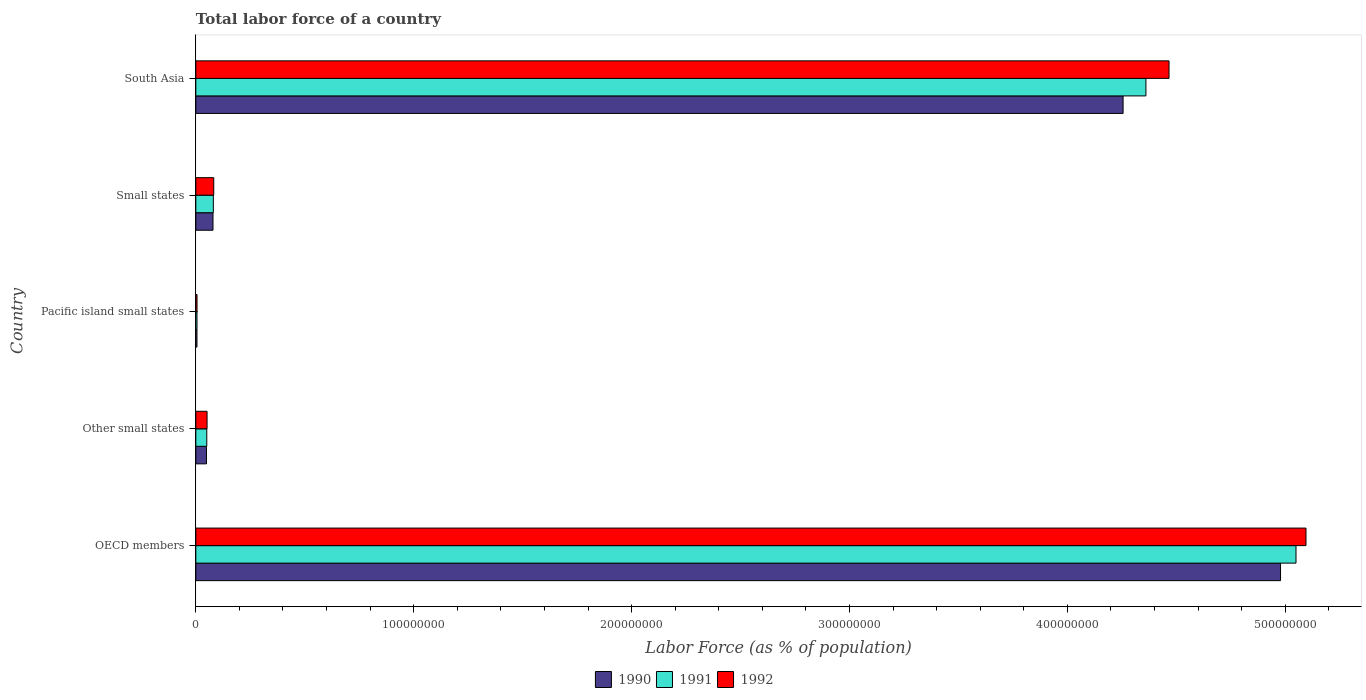How many groups of bars are there?
Provide a short and direct response. 5. Are the number of bars on each tick of the Y-axis equal?
Make the answer very short. Yes. How many bars are there on the 4th tick from the top?
Give a very brief answer. 3. How many bars are there on the 5th tick from the bottom?
Keep it short and to the point. 3. What is the label of the 3rd group of bars from the top?
Ensure brevity in your answer.  Pacific island small states. What is the percentage of labor force in 1990 in Pacific island small states?
Your response must be concise. 5.22e+05. Across all countries, what is the maximum percentage of labor force in 1992?
Make the answer very short. 5.10e+08. Across all countries, what is the minimum percentage of labor force in 1992?
Offer a terse response. 5.49e+05. In which country was the percentage of labor force in 1992 minimum?
Your response must be concise. Pacific island small states. What is the total percentage of labor force in 1991 in the graph?
Provide a short and direct response. 9.55e+08. What is the difference between the percentage of labor force in 1992 in OECD members and that in Other small states?
Your answer should be compact. 5.04e+08. What is the difference between the percentage of labor force in 1990 in Pacific island small states and the percentage of labor force in 1992 in Small states?
Ensure brevity in your answer.  -7.70e+06. What is the average percentage of labor force in 1990 per country?
Keep it short and to the point. 1.87e+08. What is the difference between the percentage of labor force in 1991 and percentage of labor force in 1992 in OECD members?
Your response must be concise. -4.58e+06. What is the ratio of the percentage of labor force in 1990 in OECD members to that in South Asia?
Make the answer very short. 1.17. Is the percentage of labor force in 1992 in OECD members less than that in Small states?
Keep it short and to the point. No. What is the difference between the highest and the second highest percentage of labor force in 1992?
Make the answer very short. 6.29e+07. What is the difference between the highest and the lowest percentage of labor force in 1991?
Make the answer very short. 5.04e+08. Is the sum of the percentage of labor force in 1990 in Pacific island small states and South Asia greater than the maximum percentage of labor force in 1992 across all countries?
Your answer should be very brief. No. What does the 2nd bar from the bottom in South Asia represents?
Provide a succinct answer. 1991. How many countries are there in the graph?
Make the answer very short. 5. What is the difference between two consecutive major ticks on the X-axis?
Offer a terse response. 1.00e+08. Does the graph contain any zero values?
Give a very brief answer. No. Does the graph contain grids?
Your answer should be very brief. No. What is the title of the graph?
Make the answer very short. Total labor force of a country. Does "1968" appear as one of the legend labels in the graph?
Provide a succinct answer. No. What is the label or title of the X-axis?
Make the answer very short. Labor Force (as % of population). What is the label or title of the Y-axis?
Your answer should be compact. Country. What is the Labor Force (as % of population) in 1990 in OECD members?
Make the answer very short. 4.98e+08. What is the Labor Force (as % of population) of 1991 in OECD members?
Offer a terse response. 5.05e+08. What is the Labor Force (as % of population) of 1992 in OECD members?
Provide a short and direct response. 5.10e+08. What is the Labor Force (as % of population) in 1990 in Other small states?
Ensure brevity in your answer.  4.89e+06. What is the Labor Force (as % of population) of 1991 in Other small states?
Ensure brevity in your answer.  5.02e+06. What is the Labor Force (as % of population) of 1992 in Other small states?
Your answer should be very brief. 5.16e+06. What is the Labor Force (as % of population) of 1990 in Pacific island small states?
Give a very brief answer. 5.22e+05. What is the Labor Force (as % of population) of 1991 in Pacific island small states?
Give a very brief answer. 5.36e+05. What is the Labor Force (as % of population) in 1992 in Pacific island small states?
Offer a terse response. 5.49e+05. What is the Labor Force (as % of population) of 1990 in Small states?
Keep it short and to the point. 7.88e+06. What is the Labor Force (as % of population) of 1991 in Small states?
Offer a very short reply. 8.04e+06. What is the Labor Force (as % of population) of 1992 in Small states?
Provide a succinct answer. 8.22e+06. What is the Labor Force (as % of population) of 1990 in South Asia?
Provide a succinct answer. 4.26e+08. What is the Labor Force (as % of population) in 1991 in South Asia?
Your answer should be very brief. 4.36e+08. What is the Labor Force (as % of population) in 1992 in South Asia?
Provide a short and direct response. 4.47e+08. Across all countries, what is the maximum Labor Force (as % of population) of 1990?
Make the answer very short. 4.98e+08. Across all countries, what is the maximum Labor Force (as % of population) of 1991?
Your answer should be compact. 5.05e+08. Across all countries, what is the maximum Labor Force (as % of population) in 1992?
Offer a terse response. 5.10e+08. Across all countries, what is the minimum Labor Force (as % of population) of 1990?
Your answer should be compact. 5.22e+05. Across all countries, what is the minimum Labor Force (as % of population) of 1991?
Ensure brevity in your answer.  5.36e+05. Across all countries, what is the minimum Labor Force (as % of population) of 1992?
Give a very brief answer. 5.49e+05. What is the total Labor Force (as % of population) of 1990 in the graph?
Your answer should be very brief. 9.37e+08. What is the total Labor Force (as % of population) of 1991 in the graph?
Give a very brief answer. 9.55e+08. What is the total Labor Force (as % of population) of 1992 in the graph?
Ensure brevity in your answer.  9.70e+08. What is the difference between the Labor Force (as % of population) of 1990 in OECD members and that in Other small states?
Your answer should be compact. 4.93e+08. What is the difference between the Labor Force (as % of population) in 1991 in OECD members and that in Other small states?
Provide a succinct answer. 5.00e+08. What is the difference between the Labor Force (as % of population) in 1992 in OECD members and that in Other small states?
Offer a terse response. 5.04e+08. What is the difference between the Labor Force (as % of population) of 1990 in OECD members and that in Pacific island small states?
Keep it short and to the point. 4.97e+08. What is the difference between the Labor Force (as % of population) in 1991 in OECD members and that in Pacific island small states?
Your response must be concise. 5.04e+08. What is the difference between the Labor Force (as % of population) of 1992 in OECD members and that in Pacific island small states?
Offer a very short reply. 5.09e+08. What is the difference between the Labor Force (as % of population) in 1990 in OECD members and that in Small states?
Your answer should be compact. 4.90e+08. What is the difference between the Labor Force (as % of population) of 1991 in OECD members and that in Small states?
Give a very brief answer. 4.97e+08. What is the difference between the Labor Force (as % of population) in 1992 in OECD members and that in Small states?
Ensure brevity in your answer.  5.01e+08. What is the difference between the Labor Force (as % of population) in 1990 in OECD members and that in South Asia?
Provide a short and direct response. 7.23e+07. What is the difference between the Labor Force (as % of population) in 1991 in OECD members and that in South Asia?
Give a very brief answer. 6.89e+07. What is the difference between the Labor Force (as % of population) of 1992 in OECD members and that in South Asia?
Offer a very short reply. 6.29e+07. What is the difference between the Labor Force (as % of population) in 1990 in Other small states and that in Pacific island small states?
Provide a short and direct response. 4.37e+06. What is the difference between the Labor Force (as % of population) of 1991 in Other small states and that in Pacific island small states?
Your response must be concise. 4.49e+06. What is the difference between the Labor Force (as % of population) in 1992 in Other small states and that in Pacific island small states?
Your answer should be compact. 4.61e+06. What is the difference between the Labor Force (as % of population) of 1990 in Other small states and that in Small states?
Your response must be concise. -2.99e+06. What is the difference between the Labor Force (as % of population) in 1991 in Other small states and that in Small states?
Your response must be concise. -3.01e+06. What is the difference between the Labor Force (as % of population) in 1992 in Other small states and that in Small states?
Your answer should be compact. -3.07e+06. What is the difference between the Labor Force (as % of population) in 1990 in Other small states and that in South Asia?
Provide a succinct answer. -4.21e+08. What is the difference between the Labor Force (as % of population) in 1991 in Other small states and that in South Asia?
Keep it short and to the point. -4.31e+08. What is the difference between the Labor Force (as % of population) in 1992 in Other small states and that in South Asia?
Ensure brevity in your answer.  -4.42e+08. What is the difference between the Labor Force (as % of population) in 1990 in Pacific island small states and that in Small states?
Offer a terse response. -7.36e+06. What is the difference between the Labor Force (as % of population) in 1991 in Pacific island small states and that in Small states?
Ensure brevity in your answer.  -7.50e+06. What is the difference between the Labor Force (as % of population) in 1992 in Pacific island small states and that in Small states?
Provide a short and direct response. -7.68e+06. What is the difference between the Labor Force (as % of population) of 1990 in Pacific island small states and that in South Asia?
Make the answer very short. -4.25e+08. What is the difference between the Labor Force (as % of population) in 1991 in Pacific island small states and that in South Asia?
Offer a terse response. -4.36e+08. What is the difference between the Labor Force (as % of population) in 1992 in Pacific island small states and that in South Asia?
Make the answer very short. -4.46e+08. What is the difference between the Labor Force (as % of population) of 1990 in Small states and that in South Asia?
Provide a short and direct response. -4.18e+08. What is the difference between the Labor Force (as % of population) in 1991 in Small states and that in South Asia?
Provide a succinct answer. -4.28e+08. What is the difference between the Labor Force (as % of population) in 1992 in Small states and that in South Asia?
Your response must be concise. -4.38e+08. What is the difference between the Labor Force (as % of population) in 1990 in OECD members and the Labor Force (as % of population) in 1991 in Other small states?
Make the answer very short. 4.93e+08. What is the difference between the Labor Force (as % of population) of 1990 in OECD members and the Labor Force (as % of population) of 1992 in Other small states?
Make the answer very short. 4.93e+08. What is the difference between the Labor Force (as % of population) of 1991 in OECD members and the Labor Force (as % of population) of 1992 in Other small states?
Your answer should be compact. 5.00e+08. What is the difference between the Labor Force (as % of population) of 1990 in OECD members and the Labor Force (as % of population) of 1991 in Pacific island small states?
Your answer should be very brief. 4.97e+08. What is the difference between the Labor Force (as % of population) in 1990 in OECD members and the Labor Force (as % of population) in 1992 in Pacific island small states?
Ensure brevity in your answer.  4.97e+08. What is the difference between the Labor Force (as % of population) in 1991 in OECD members and the Labor Force (as % of population) in 1992 in Pacific island small states?
Your response must be concise. 5.04e+08. What is the difference between the Labor Force (as % of population) in 1990 in OECD members and the Labor Force (as % of population) in 1991 in Small states?
Ensure brevity in your answer.  4.90e+08. What is the difference between the Labor Force (as % of population) in 1990 in OECD members and the Labor Force (as % of population) in 1992 in Small states?
Provide a succinct answer. 4.90e+08. What is the difference between the Labor Force (as % of population) in 1991 in OECD members and the Labor Force (as % of population) in 1992 in Small states?
Give a very brief answer. 4.97e+08. What is the difference between the Labor Force (as % of population) of 1990 in OECD members and the Labor Force (as % of population) of 1991 in South Asia?
Ensure brevity in your answer.  6.18e+07. What is the difference between the Labor Force (as % of population) of 1990 in OECD members and the Labor Force (as % of population) of 1992 in South Asia?
Make the answer very short. 5.12e+07. What is the difference between the Labor Force (as % of population) of 1991 in OECD members and the Labor Force (as % of population) of 1992 in South Asia?
Your response must be concise. 5.83e+07. What is the difference between the Labor Force (as % of population) in 1990 in Other small states and the Labor Force (as % of population) in 1991 in Pacific island small states?
Offer a terse response. 4.36e+06. What is the difference between the Labor Force (as % of population) in 1990 in Other small states and the Labor Force (as % of population) in 1992 in Pacific island small states?
Ensure brevity in your answer.  4.34e+06. What is the difference between the Labor Force (as % of population) in 1991 in Other small states and the Labor Force (as % of population) in 1992 in Pacific island small states?
Your answer should be compact. 4.48e+06. What is the difference between the Labor Force (as % of population) in 1990 in Other small states and the Labor Force (as % of population) in 1991 in Small states?
Keep it short and to the point. -3.14e+06. What is the difference between the Labor Force (as % of population) of 1990 in Other small states and the Labor Force (as % of population) of 1992 in Small states?
Ensure brevity in your answer.  -3.33e+06. What is the difference between the Labor Force (as % of population) of 1991 in Other small states and the Labor Force (as % of population) of 1992 in Small states?
Your answer should be compact. -3.20e+06. What is the difference between the Labor Force (as % of population) in 1990 in Other small states and the Labor Force (as % of population) in 1991 in South Asia?
Your answer should be compact. -4.31e+08. What is the difference between the Labor Force (as % of population) of 1990 in Other small states and the Labor Force (as % of population) of 1992 in South Asia?
Your answer should be compact. -4.42e+08. What is the difference between the Labor Force (as % of population) in 1991 in Other small states and the Labor Force (as % of population) in 1992 in South Asia?
Keep it short and to the point. -4.42e+08. What is the difference between the Labor Force (as % of population) in 1990 in Pacific island small states and the Labor Force (as % of population) in 1991 in Small states?
Give a very brief answer. -7.51e+06. What is the difference between the Labor Force (as % of population) of 1990 in Pacific island small states and the Labor Force (as % of population) of 1992 in Small states?
Provide a short and direct response. -7.70e+06. What is the difference between the Labor Force (as % of population) of 1991 in Pacific island small states and the Labor Force (as % of population) of 1992 in Small states?
Offer a terse response. -7.69e+06. What is the difference between the Labor Force (as % of population) in 1990 in Pacific island small states and the Labor Force (as % of population) in 1991 in South Asia?
Provide a short and direct response. -4.36e+08. What is the difference between the Labor Force (as % of population) in 1990 in Pacific island small states and the Labor Force (as % of population) in 1992 in South Asia?
Offer a terse response. -4.46e+08. What is the difference between the Labor Force (as % of population) of 1991 in Pacific island small states and the Labor Force (as % of population) of 1992 in South Asia?
Your answer should be compact. -4.46e+08. What is the difference between the Labor Force (as % of population) in 1990 in Small states and the Labor Force (as % of population) in 1991 in South Asia?
Provide a short and direct response. -4.28e+08. What is the difference between the Labor Force (as % of population) in 1990 in Small states and the Labor Force (as % of population) in 1992 in South Asia?
Your answer should be very brief. -4.39e+08. What is the difference between the Labor Force (as % of population) in 1991 in Small states and the Labor Force (as % of population) in 1992 in South Asia?
Make the answer very short. -4.39e+08. What is the average Labor Force (as % of population) of 1990 per country?
Offer a very short reply. 1.87e+08. What is the average Labor Force (as % of population) in 1991 per country?
Provide a short and direct response. 1.91e+08. What is the average Labor Force (as % of population) in 1992 per country?
Give a very brief answer. 1.94e+08. What is the difference between the Labor Force (as % of population) of 1990 and Labor Force (as % of population) of 1991 in OECD members?
Provide a short and direct response. -7.11e+06. What is the difference between the Labor Force (as % of population) of 1990 and Labor Force (as % of population) of 1992 in OECD members?
Make the answer very short. -1.17e+07. What is the difference between the Labor Force (as % of population) of 1991 and Labor Force (as % of population) of 1992 in OECD members?
Make the answer very short. -4.58e+06. What is the difference between the Labor Force (as % of population) of 1990 and Labor Force (as % of population) of 1991 in Other small states?
Offer a terse response. -1.31e+05. What is the difference between the Labor Force (as % of population) of 1990 and Labor Force (as % of population) of 1992 in Other small states?
Your answer should be very brief. -2.64e+05. What is the difference between the Labor Force (as % of population) in 1991 and Labor Force (as % of population) in 1992 in Other small states?
Ensure brevity in your answer.  -1.33e+05. What is the difference between the Labor Force (as % of population) in 1990 and Labor Force (as % of population) in 1991 in Pacific island small states?
Offer a very short reply. -1.31e+04. What is the difference between the Labor Force (as % of population) in 1990 and Labor Force (as % of population) in 1992 in Pacific island small states?
Offer a terse response. -2.65e+04. What is the difference between the Labor Force (as % of population) in 1991 and Labor Force (as % of population) in 1992 in Pacific island small states?
Give a very brief answer. -1.34e+04. What is the difference between the Labor Force (as % of population) of 1990 and Labor Force (as % of population) of 1991 in Small states?
Provide a succinct answer. -1.54e+05. What is the difference between the Labor Force (as % of population) of 1990 and Labor Force (as % of population) of 1992 in Small states?
Make the answer very short. -3.42e+05. What is the difference between the Labor Force (as % of population) in 1991 and Labor Force (as % of population) in 1992 in Small states?
Your answer should be very brief. -1.89e+05. What is the difference between the Labor Force (as % of population) of 1990 and Labor Force (as % of population) of 1991 in South Asia?
Keep it short and to the point. -1.05e+07. What is the difference between the Labor Force (as % of population) in 1990 and Labor Force (as % of population) in 1992 in South Asia?
Make the answer very short. -2.11e+07. What is the difference between the Labor Force (as % of population) of 1991 and Labor Force (as % of population) of 1992 in South Asia?
Your answer should be compact. -1.06e+07. What is the ratio of the Labor Force (as % of population) of 1990 in OECD members to that in Other small states?
Give a very brief answer. 101.74. What is the ratio of the Labor Force (as % of population) in 1991 in OECD members to that in Other small states?
Provide a short and direct response. 100.5. What is the ratio of the Labor Force (as % of population) of 1992 in OECD members to that in Other small states?
Provide a short and direct response. 98.79. What is the ratio of the Labor Force (as % of population) in 1990 in OECD members to that in Pacific island small states?
Your response must be concise. 952.94. What is the ratio of the Labor Force (as % of population) in 1991 in OECD members to that in Pacific island small states?
Your response must be concise. 942.93. What is the ratio of the Labor Force (as % of population) of 1992 in OECD members to that in Pacific island small states?
Make the answer very short. 928.24. What is the ratio of the Labor Force (as % of population) of 1990 in OECD members to that in Small states?
Your answer should be compact. 63.16. What is the ratio of the Labor Force (as % of population) of 1991 in OECD members to that in Small states?
Offer a terse response. 62.84. What is the ratio of the Labor Force (as % of population) in 1992 in OECD members to that in Small states?
Provide a short and direct response. 61.95. What is the ratio of the Labor Force (as % of population) in 1990 in OECD members to that in South Asia?
Provide a succinct answer. 1.17. What is the ratio of the Labor Force (as % of population) in 1991 in OECD members to that in South Asia?
Your answer should be compact. 1.16. What is the ratio of the Labor Force (as % of population) of 1992 in OECD members to that in South Asia?
Your answer should be compact. 1.14. What is the ratio of the Labor Force (as % of population) of 1990 in Other small states to that in Pacific island small states?
Keep it short and to the point. 9.37. What is the ratio of the Labor Force (as % of population) of 1991 in Other small states to that in Pacific island small states?
Provide a short and direct response. 9.38. What is the ratio of the Labor Force (as % of population) in 1992 in Other small states to that in Pacific island small states?
Your response must be concise. 9.4. What is the ratio of the Labor Force (as % of population) in 1990 in Other small states to that in Small states?
Offer a very short reply. 0.62. What is the ratio of the Labor Force (as % of population) in 1991 in Other small states to that in Small states?
Offer a terse response. 0.63. What is the ratio of the Labor Force (as % of population) of 1992 in Other small states to that in Small states?
Make the answer very short. 0.63. What is the ratio of the Labor Force (as % of population) in 1990 in Other small states to that in South Asia?
Provide a succinct answer. 0.01. What is the ratio of the Labor Force (as % of population) in 1991 in Other small states to that in South Asia?
Provide a short and direct response. 0.01. What is the ratio of the Labor Force (as % of population) in 1992 in Other small states to that in South Asia?
Make the answer very short. 0.01. What is the ratio of the Labor Force (as % of population) of 1990 in Pacific island small states to that in Small states?
Offer a terse response. 0.07. What is the ratio of the Labor Force (as % of population) of 1991 in Pacific island small states to that in Small states?
Your answer should be compact. 0.07. What is the ratio of the Labor Force (as % of population) in 1992 in Pacific island small states to that in Small states?
Provide a succinct answer. 0.07. What is the ratio of the Labor Force (as % of population) in 1990 in Pacific island small states to that in South Asia?
Provide a succinct answer. 0. What is the ratio of the Labor Force (as % of population) in 1991 in Pacific island small states to that in South Asia?
Your response must be concise. 0. What is the ratio of the Labor Force (as % of population) in 1992 in Pacific island small states to that in South Asia?
Keep it short and to the point. 0. What is the ratio of the Labor Force (as % of population) in 1990 in Small states to that in South Asia?
Give a very brief answer. 0.02. What is the ratio of the Labor Force (as % of population) of 1991 in Small states to that in South Asia?
Make the answer very short. 0.02. What is the ratio of the Labor Force (as % of population) of 1992 in Small states to that in South Asia?
Ensure brevity in your answer.  0.02. What is the difference between the highest and the second highest Labor Force (as % of population) in 1990?
Your answer should be very brief. 7.23e+07. What is the difference between the highest and the second highest Labor Force (as % of population) of 1991?
Offer a terse response. 6.89e+07. What is the difference between the highest and the second highest Labor Force (as % of population) in 1992?
Provide a succinct answer. 6.29e+07. What is the difference between the highest and the lowest Labor Force (as % of population) in 1990?
Ensure brevity in your answer.  4.97e+08. What is the difference between the highest and the lowest Labor Force (as % of population) in 1991?
Your response must be concise. 5.04e+08. What is the difference between the highest and the lowest Labor Force (as % of population) in 1992?
Offer a terse response. 5.09e+08. 